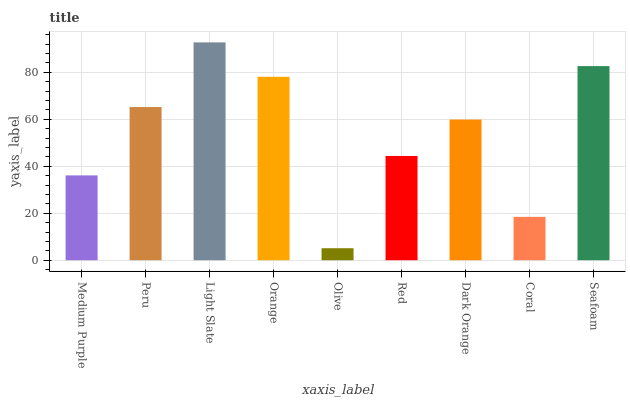Is Olive the minimum?
Answer yes or no. Yes. Is Light Slate the maximum?
Answer yes or no. Yes. Is Peru the minimum?
Answer yes or no. No. Is Peru the maximum?
Answer yes or no. No. Is Peru greater than Medium Purple?
Answer yes or no. Yes. Is Medium Purple less than Peru?
Answer yes or no. Yes. Is Medium Purple greater than Peru?
Answer yes or no. No. Is Peru less than Medium Purple?
Answer yes or no. No. Is Dark Orange the high median?
Answer yes or no. Yes. Is Dark Orange the low median?
Answer yes or no. Yes. Is Light Slate the high median?
Answer yes or no. No. Is Red the low median?
Answer yes or no. No. 